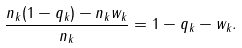<formula> <loc_0><loc_0><loc_500><loc_500>\frac { n _ { k } ( 1 - q _ { k } ) - n _ { k } w _ { k } } { n _ { k } } = 1 - q _ { k } - w _ { k } .</formula> 